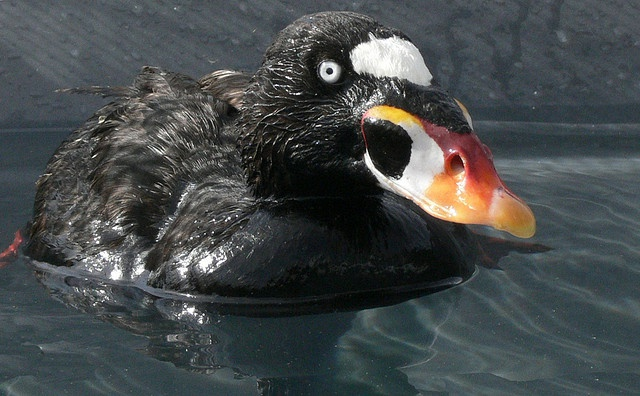Describe the objects in this image and their specific colors. I can see a bird in gray, black, lightgray, and darkgray tones in this image. 